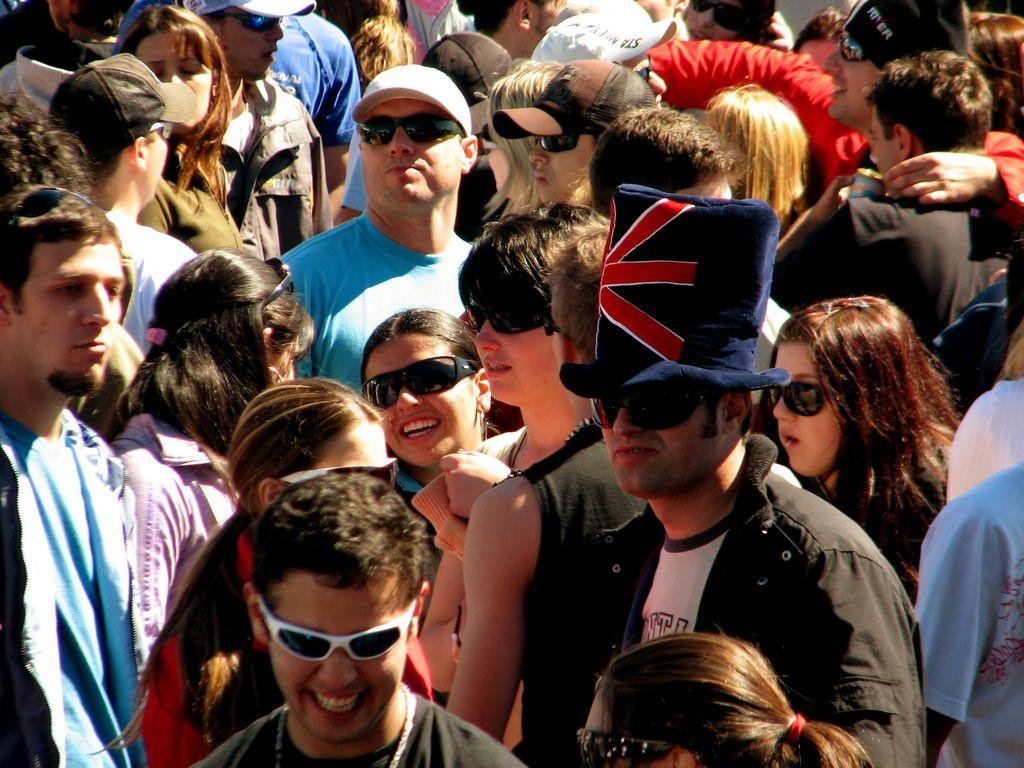Where was the image likely taken? The image appears to be taken outdoors. What can be seen in the image? There is a group of people in the image. What is the position of the people in the image? The people are standing on the ground. What type of plate is being used by the people in the image? There is no plate visible in the image; the people are standing on the ground. 